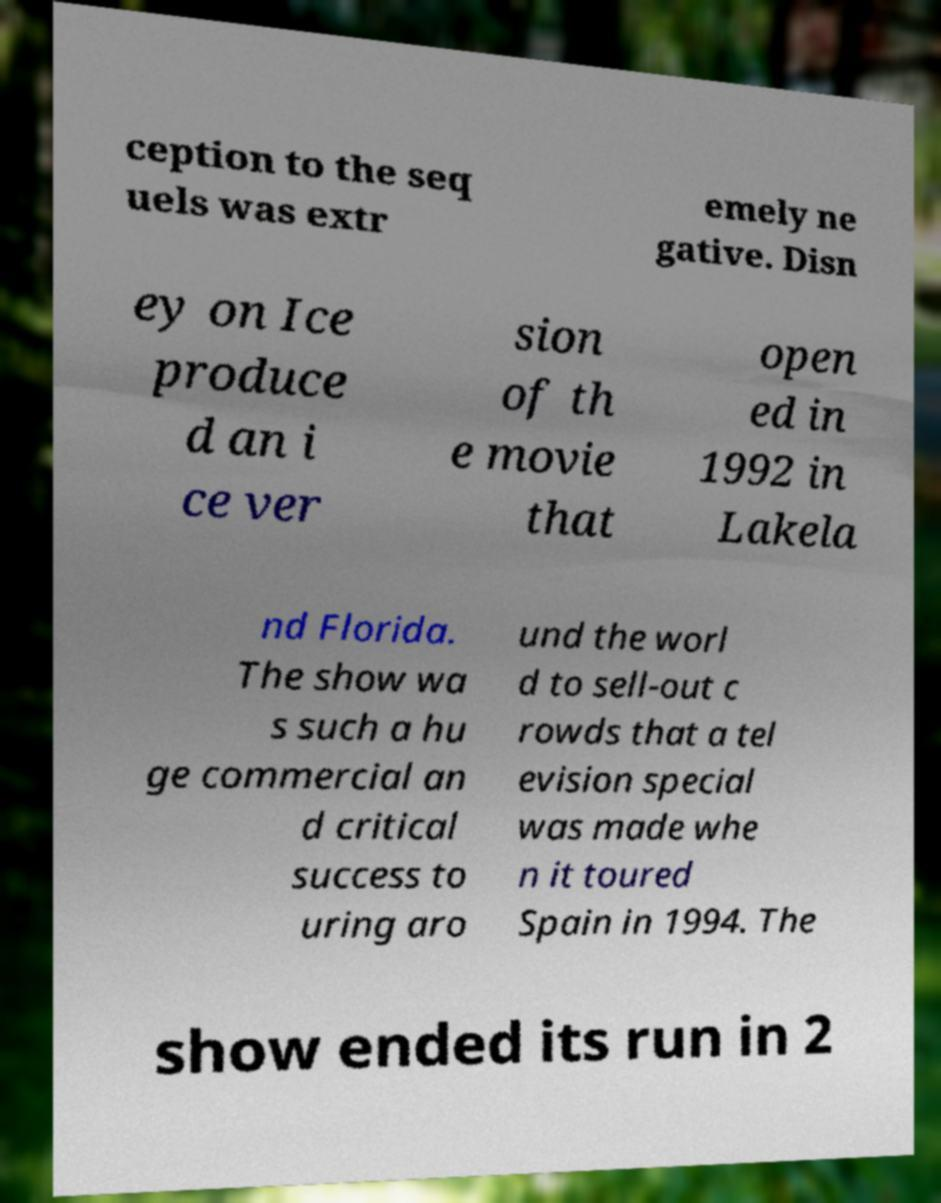Please identify and transcribe the text found in this image. ception to the seq uels was extr emely ne gative. Disn ey on Ice produce d an i ce ver sion of th e movie that open ed in 1992 in Lakela nd Florida. The show wa s such a hu ge commercial an d critical success to uring aro und the worl d to sell-out c rowds that a tel evision special was made whe n it toured Spain in 1994. The show ended its run in 2 